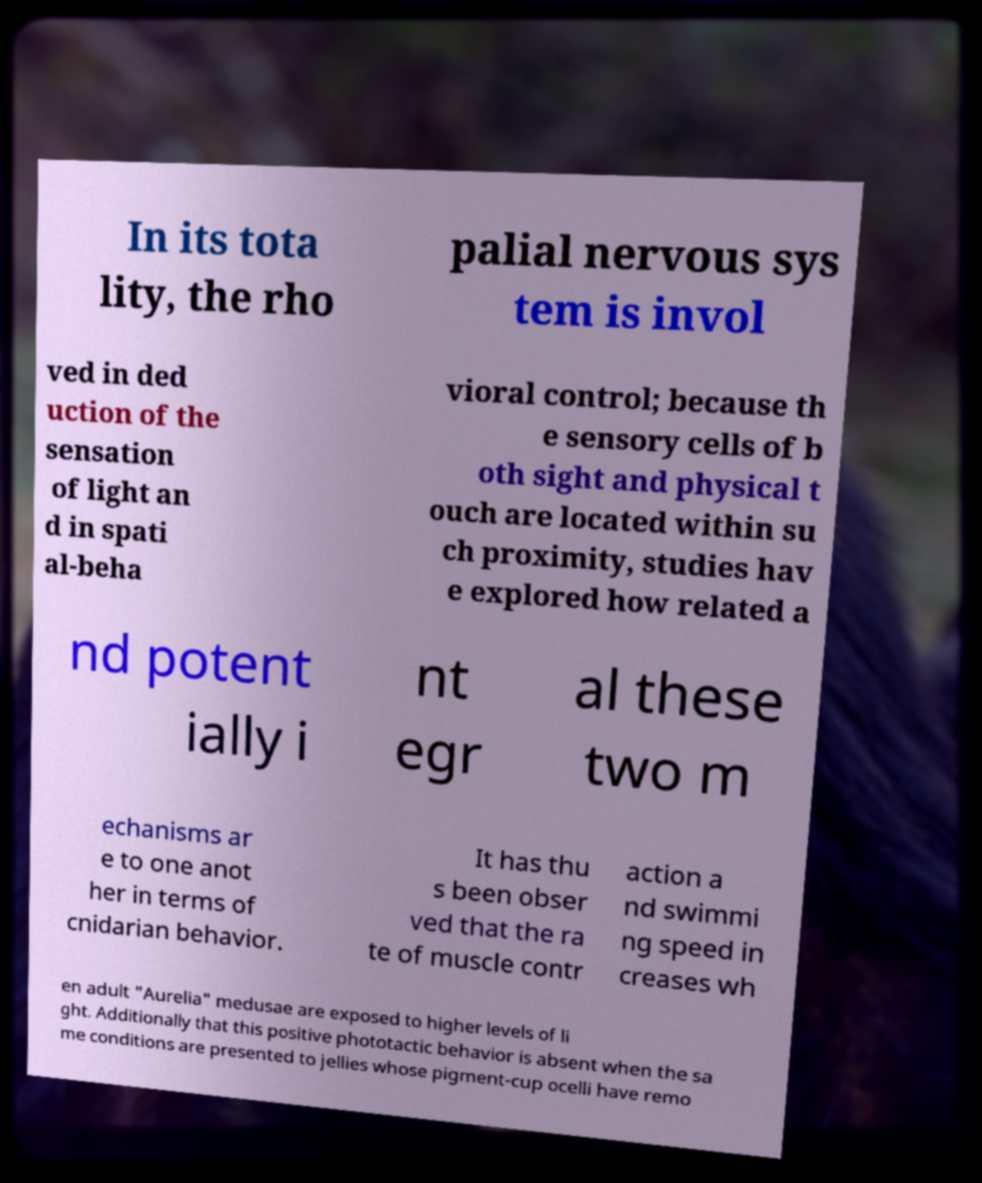There's text embedded in this image that I need extracted. Can you transcribe it verbatim? In its tota lity, the rho palial nervous sys tem is invol ved in ded uction of the sensation of light an d in spati al-beha vioral control; because th e sensory cells of b oth sight and physical t ouch are located within su ch proximity, studies hav e explored how related a nd potent ially i nt egr al these two m echanisms ar e to one anot her in terms of cnidarian behavior. It has thu s been obser ved that the ra te of muscle contr action a nd swimmi ng speed in creases wh en adult "Aurelia" medusae are exposed to higher levels of li ght. Additionally that this positive phototactic behavior is absent when the sa me conditions are presented to jellies whose pigment-cup ocelli have remo 